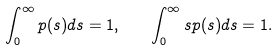<formula> <loc_0><loc_0><loc_500><loc_500>\int _ { 0 } ^ { \infty } p ( s ) d s = 1 , \quad \int _ { 0 } ^ { \infty } s p ( s ) d s = 1 .</formula> 